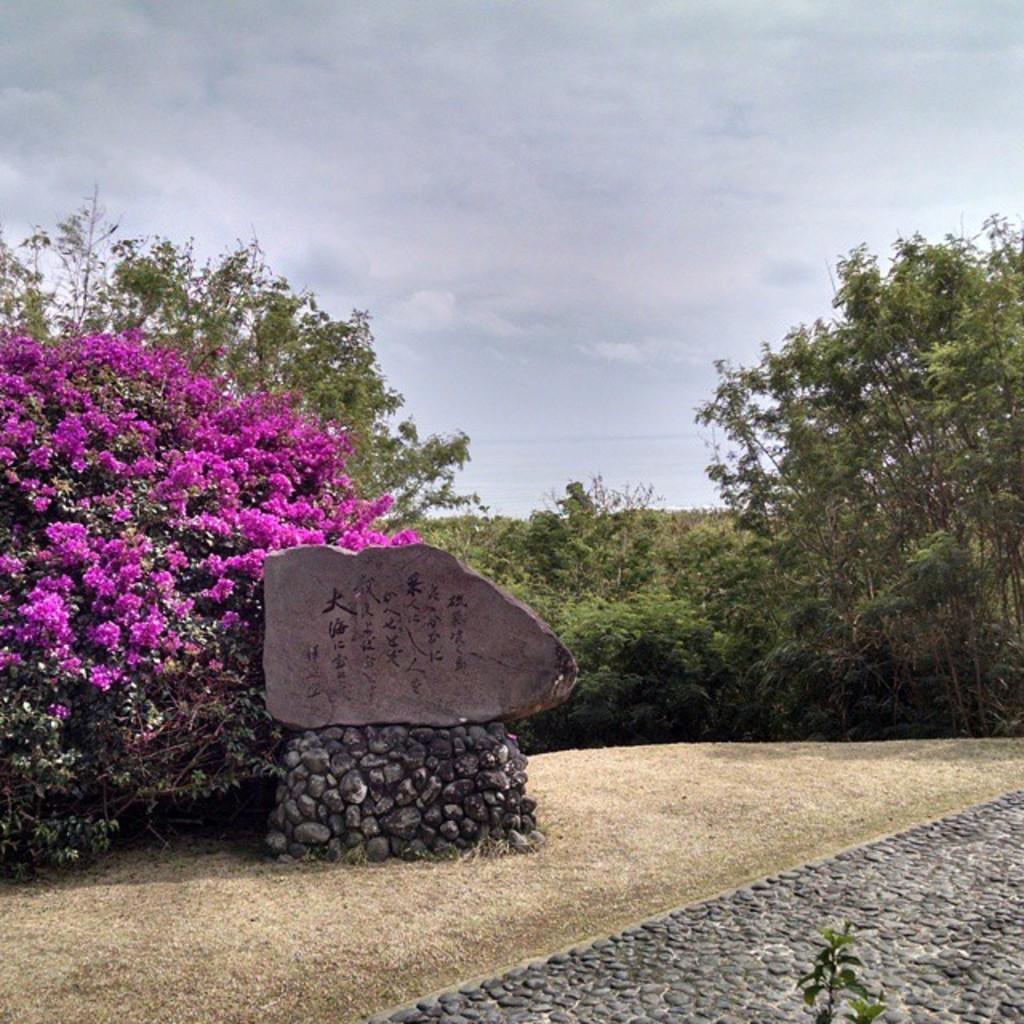Describe this image in one or two sentences. This image is clicked outside. There are plants in the middle. There is sky at the top. There are flowers on the left side. They are in pink color. 